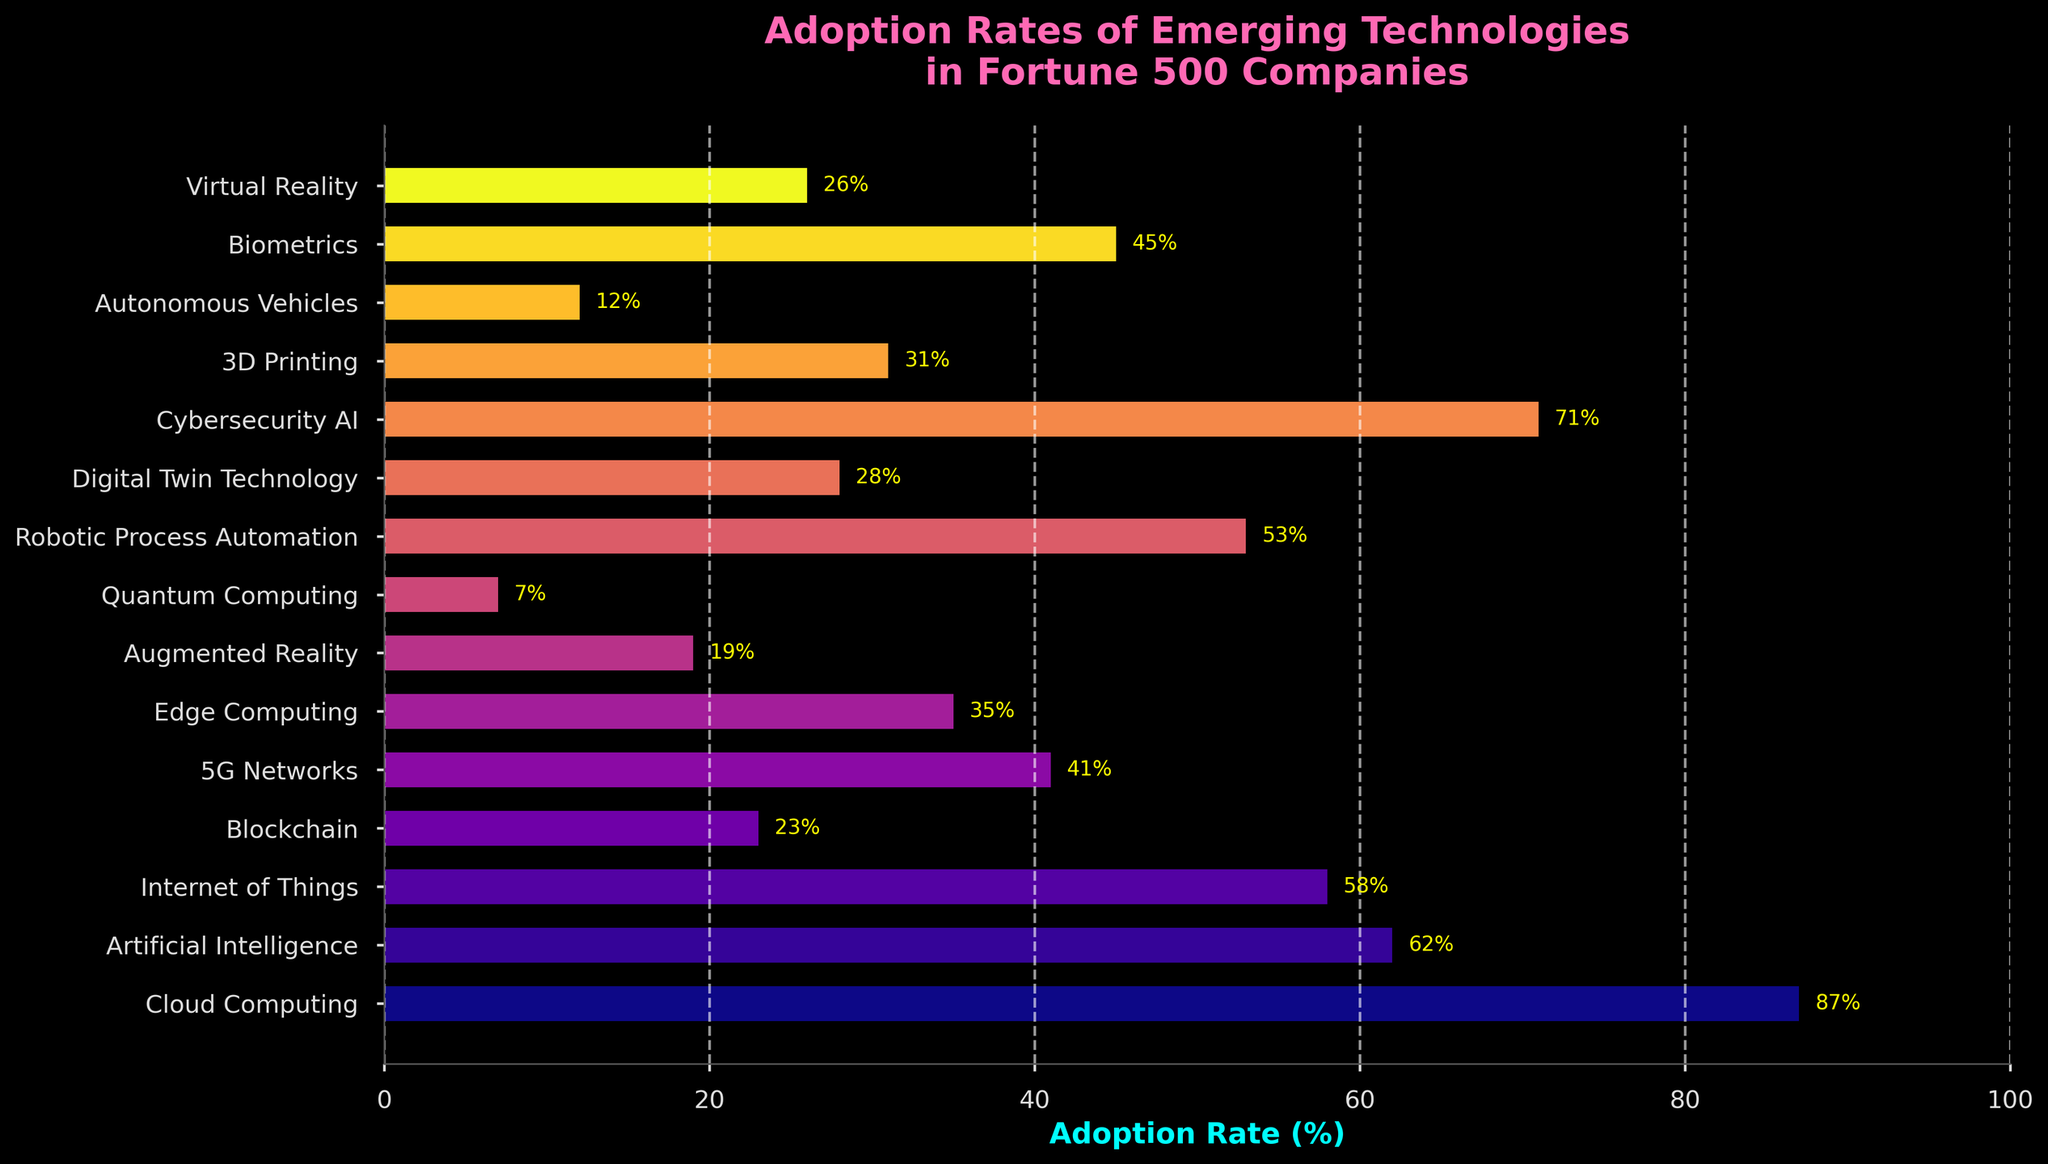Which technology has the highest adoption rate? Identify the bar that is the longest among all. Cloud Computing has the highest adoption rate at 87%.
Answer: Cloud Computing What is the difference in adoption rates between Artificial Intelligence and 5G Networks? The adoption rate of Artificial Intelligence is 62%, and for 5G Networks, it is 41%. The difference is 62 - 41 = 21.
Answer: 21 What is the average adoption rate of Blockchain, Edge Computing, and Digital Twin Technology? The adoption rates are Blockchain (23%), Edge Computing (35%), and Digital Twin Technology (28%). Calculate the average: (23 + 35 + 28) / 3 = 28.67%.
Answer: 28.67% Which technology has a lower adoption rate, Virtual Reality or Augmented Reality? Compare the lengths of the bars for Virtual Reality (26%) and Augmented Reality (19%). Augmented Reality has a lower adoption rate.
Answer: Augmented Reality What is the adoption rate range for all the technologies? Identify the maximum adoption rate (Cloud Computing: 87%) and the minimum adoption rate (Quantum Computing: 7%). The range is 87 - 7 = 80.
Answer: 80 List the technologies with an adoption rate greater than 50%. Identify bars longer than 50%: Cloud Computing (87%), Artificial Intelligence (62%), Internet of Things (58%), Cybersecurity AI (71%), Robotic Process Automation (53%).
Answer: Cloud Computing, Artificial Intelligence, Internet of Things, Cybersecurity AI, Robotic Process Automation What is the sum of adoption rates for cybersecurity technologies (Cybersecurity AI and Biometrics)? Sum the adoption rates of Cybersecurity AI (71%) and Biometrics (45%). 71 + 45 = 116.
Answer: 116 Which technology with an adoption rate less than 30% has the highest adoption rate? List technologies less than 30% adoption: Blockchain (23%), Augmented Reality (19%), Quantum Computing (7%), Digital Twin Technology (28%), Virtual Reality (26%), Autonomous Vehicles (12%). Digital Twin Technology has the highest in this subset.
Answer: Digital Twin Technology By how much does the adoption rate of Internet of Things exceed that of 3D Printing? Adoption rate of Internet of Things (58%) minus adoption rate of 3D Printing (31%) is 58 - 31 = 27.
Answer: 27 